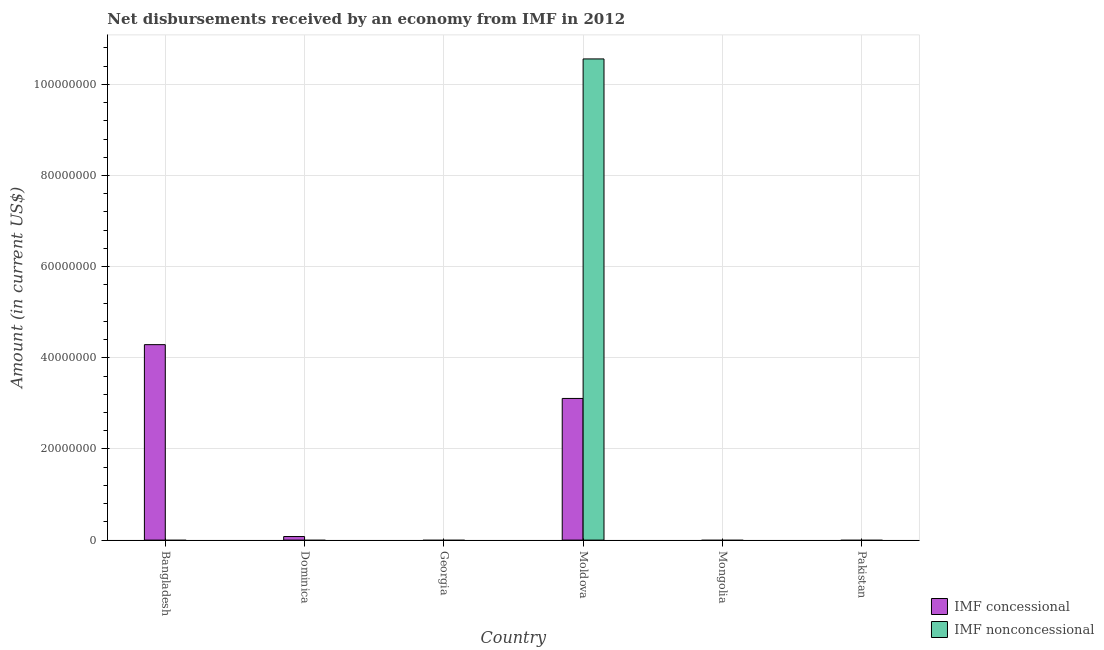Are the number of bars on each tick of the X-axis equal?
Provide a short and direct response. No. How many bars are there on the 1st tick from the left?
Provide a short and direct response. 1. How many bars are there on the 6th tick from the right?
Keep it short and to the point. 1. What is the label of the 4th group of bars from the left?
Give a very brief answer. Moldova. What is the net non concessional disbursements from imf in Moldova?
Make the answer very short. 1.06e+08. Across all countries, what is the maximum net concessional disbursements from imf?
Your response must be concise. 4.29e+07. Across all countries, what is the minimum net non concessional disbursements from imf?
Make the answer very short. 0. In which country was the net non concessional disbursements from imf maximum?
Give a very brief answer. Moldova. What is the total net non concessional disbursements from imf in the graph?
Your answer should be compact. 1.06e+08. What is the difference between the net concessional disbursements from imf in Bangladesh and that in Dominica?
Make the answer very short. 4.21e+07. What is the difference between the net non concessional disbursements from imf in Bangladesh and the net concessional disbursements from imf in Dominica?
Offer a terse response. -7.83e+05. What is the average net concessional disbursements from imf per country?
Keep it short and to the point. 1.25e+07. What is the difference between the net non concessional disbursements from imf and net concessional disbursements from imf in Moldova?
Keep it short and to the point. 7.45e+07. In how many countries, is the net non concessional disbursements from imf greater than 76000000 US$?
Give a very brief answer. 1. What is the ratio of the net concessional disbursements from imf in Bangladesh to that in Moldova?
Your response must be concise. 1.38. Is the net concessional disbursements from imf in Bangladesh less than that in Dominica?
Ensure brevity in your answer.  No. What is the difference between the highest and the second highest net concessional disbursements from imf?
Give a very brief answer. 1.18e+07. What is the difference between the highest and the lowest net non concessional disbursements from imf?
Ensure brevity in your answer.  1.06e+08. In how many countries, is the net non concessional disbursements from imf greater than the average net non concessional disbursements from imf taken over all countries?
Your answer should be compact. 1. How many bars are there?
Your answer should be compact. 4. Are all the bars in the graph horizontal?
Offer a terse response. No. How many countries are there in the graph?
Ensure brevity in your answer.  6. Are the values on the major ticks of Y-axis written in scientific E-notation?
Offer a terse response. No. How are the legend labels stacked?
Your answer should be compact. Vertical. What is the title of the graph?
Ensure brevity in your answer.  Net disbursements received by an economy from IMF in 2012. What is the label or title of the X-axis?
Make the answer very short. Country. What is the label or title of the Y-axis?
Your response must be concise. Amount (in current US$). What is the Amount (in current US$) in IMF concessional in Bangladesh?
Provide a succinct answer. 4.29e+07. What is the Amount (in current US$) in IMF concessional in Dominica?
Your answer should be compact. 7.83e+05. What is the Amount (in current US$) in IMF nonconcessional in Georgia?
Your answer should be compact. 0. What is the Amount (in current US$) of IMF concessional in Moldova?
Make the answer very short. 3.11e+07. What is the Amount (in current US$) in IMF nonconcessional in Moldova?
Provide a short and direct response. 1.06e+08. What is the Amount (in current US$) in IMF nonconcessional in Mongolia?
Your answer should be compact. 0. What is the Amount (in current US$) of IMF concessional in Pakistan?
Provide a succinct answer. 0. What is the Amount (in current US$) of IMF nonconcessional in Pakistan?
Your answer should be very brief. 0. Across all countries, what is the maximum Amount (in current US$) in IMF concessional?
Your response must be concise. 4.29e+07. Across all countries, what is the maximum Amount (in current US$) in IMF nonconcessional?
Make the answer very short. 1.06e+08. Across all countries, what is the minimum Amount (in current US$) of IMF nonconcessional?
Make the answer very short. 0. What is the total Amount (in current US$) in IMF concessional in the graph?
Your answer should be compact. 7.48e+07. What is the total Amount (in current US$) of IMF nonconcessional in the graph?
Provide a short and direct response. 1.06e+08. What is the difference between the Amount (in current US$) in IMF concessional in Bangladesh and that in Dominica?
Provide a short and direct response. 4.21e+07. What is the difference between the Amount (in current US$) in IMF concessional in Bangladesh and that in Moldova?
Offer a terse response. 1.18e+07. What is the difference between the Amount (in current US$) of IMF concessional in Dominica and that in Moldova?
Your answer should be compact. -3.03e+07. What is the difference between the Amount (in current US$) of IMF concessional in Bangladesh and the Amount (in current US$) of IMF nonconcessional in Moldova?
Provide a succinct answer. -6.27e+07. What is the difference between the Amount (in current US$) of IMF concessional in Dominica and the Amount (in current US$) of IMF nonconcessional in Moldova?
Provide a succinct answer. -1.05e+08. What is the average Amount (in current US$) of IMF concessional per country?
Ensure brevity in your answer.  1.25e+07. What is the average Amount (in current US$) of IMF nonconcessional per country?
Make the answer very short. 1.76e+07. What is the difference between the Amount (in current US$) in IMF concessional and Amount (in current US$) in IMF nonconcessional in Moldova?
Ensure brevity in your answer.  -7.45e+07. What is the ratio of the Amount (in current US$) of IMF concessional in Bangladesh to that in Dominica?
Your answer should be very brief. 54.78. What is the ratio of the Amount (in current US$) in IMF concessional in Bangladesh to that in Moldova?
Ensure brevity in your answer.  1.38. What is the ratio of the Amount (in current US$) in IMF concessional in Dominica to that in Moldova?
Make the answer very short. 0.03. What is the difference between the highest and the second highest Amount (in current US$) in IMF concessional?
Your answer should be very brief. 1.18e+07. What is the difference between the highest and the lowest Amount (in current US$) of IMF concessional?
Provide a short and direct response. 4.29e+07. What is the difference between the highest and the lowest Amount (in current US$) in IMF nonconcessional?
Your response must be concise. 1.06e+08. 